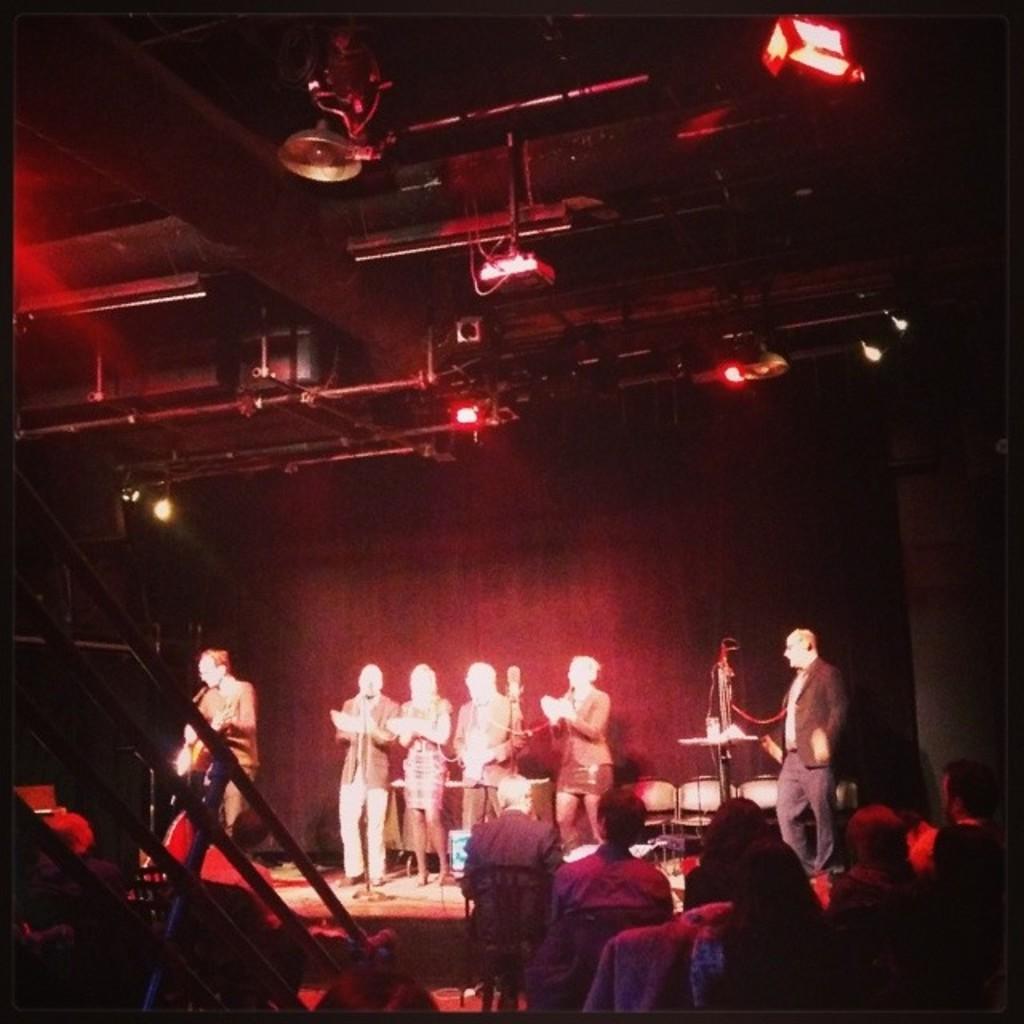Could you give a brief overview of what you see in this image? In this picture, we can see a group of people standing on the stage and a person is holding a guitar and in front of the people there are groups of people sitting on chairs and there are lights on the top. 